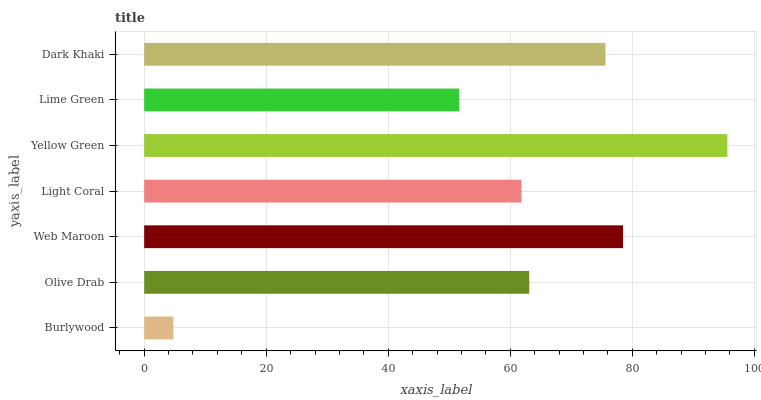Is Burlywood the minimum?
Answer yes or no. Yes. Is Yellow Green the maximum?
Answer yes or no. Yes. Is Olive Drab the minimum?
Answer yes or no. No. Is Olive Drab the maximum?
Answer yes or no. No. Is Olive Drab greater than Burlywood?
Answer yes or no. Yes. Is Burlywood less than Olive Drab?
Answer yes or no. Yes. Is Burlywood greater than Olive Drab?
Answer yes or no. No. Is Olive Drab less than Burlywood?
Answer yes or no. No. Is Olive Drab the high median?
Answer yes or no. Yes. Is Olive Drab the low median?
Answer yes or no. Yes. Is Dark Khaki the high median?
Answer yes or no. No. Is Web Maroon the low median?
Answer yes or no. No. 